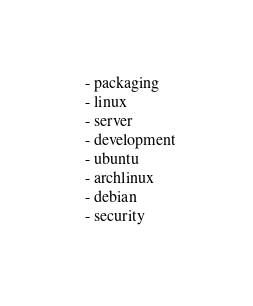Convert code to text. <code><loc_0><loc_0><loc_500><loc_500><_YAML_>  - packaging
  - linux
  - server
  - development
  - ubuntu
  - archlinux
  - debian
  - security</code> 